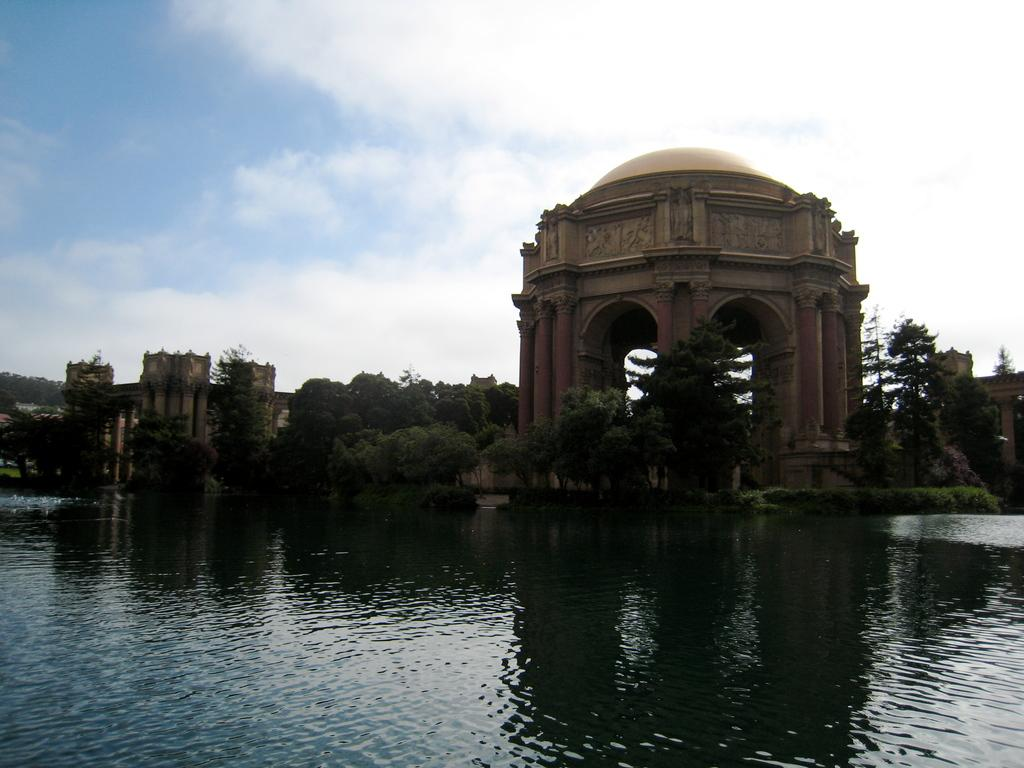What is the primary element visible in the image? There is water in the image. What types of vegetation can be seen in the image? There are plants and trees in the image. What type of natural environment is depicted in the image? The image features forests. What is visible in the background of the image? The sky is visible in the background of the image. What can be observed in the sky? There are clouds in the sky. What type of engine can be seen powering a vehicle in the image? There is no engine or vehicle present in the image; it features water, plants, trees, forests, and a sky with clouds. 